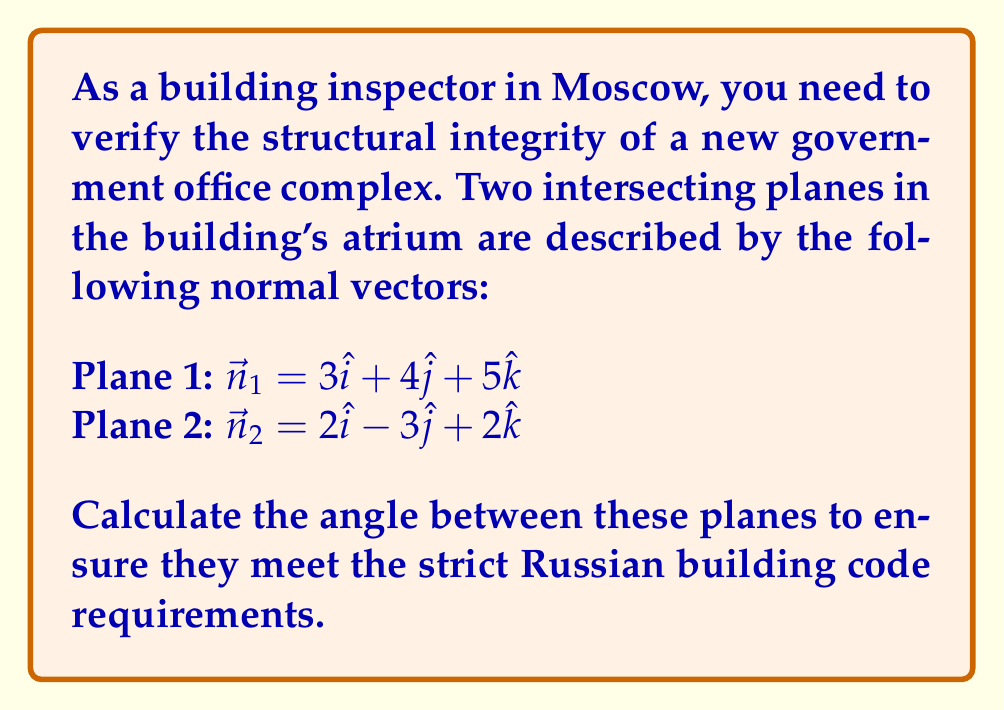Can you answer this question? To find the angle between two intersecting planes, we can use the dot product of their normal vectors. The formula is:

$$\cos \theta = \frac{|\vec{n}_1 \cdot \vec{n}_2|}{|\vec{n}_1| |\vec{n}_2|}$$

Where $\theta$ is the angle between the planes, $\vec{n}_1$ and $\vec{n}_2$ are the normal vectors of the planes.

Step 1: Calculate the dot product $\vec{n}_1 \cdot \vec{n}_2$
$$\vec{n}_1 \cdot \vec{n}_2 = (3)(2) + (4)(-3) + (5)(2) = 6 - 12 + 10 = 4$$

Step 2: Calculate the magnitudes of the normal vectors
$$|\vec{n}_1| = \sqrt{3^2 + 4^2 + 5^2} = \sqrt{50}$$
$$|\vec{n}_2| = \sqrt{2^2 + (-3)^2 + 2^2} = \sqrt{17}$$

Step 3: Apply the formula
$$\cos \theta = \frac{|4|}{\sqrt{50} \sqrt{17}} = \frac{4}{\sqrt{850}}$$

Step 4: Take the inverse cosine (arccos) of both sides
$$\theta = \arccos\left(\frac{4}{\sqrt{850}}\right)$$

Step 5: Calculate the final result
$$\theta \approx 1.4088 \text{ radians} \approx 80.73^\circ$$
Answer: $80.73^\circ$ 